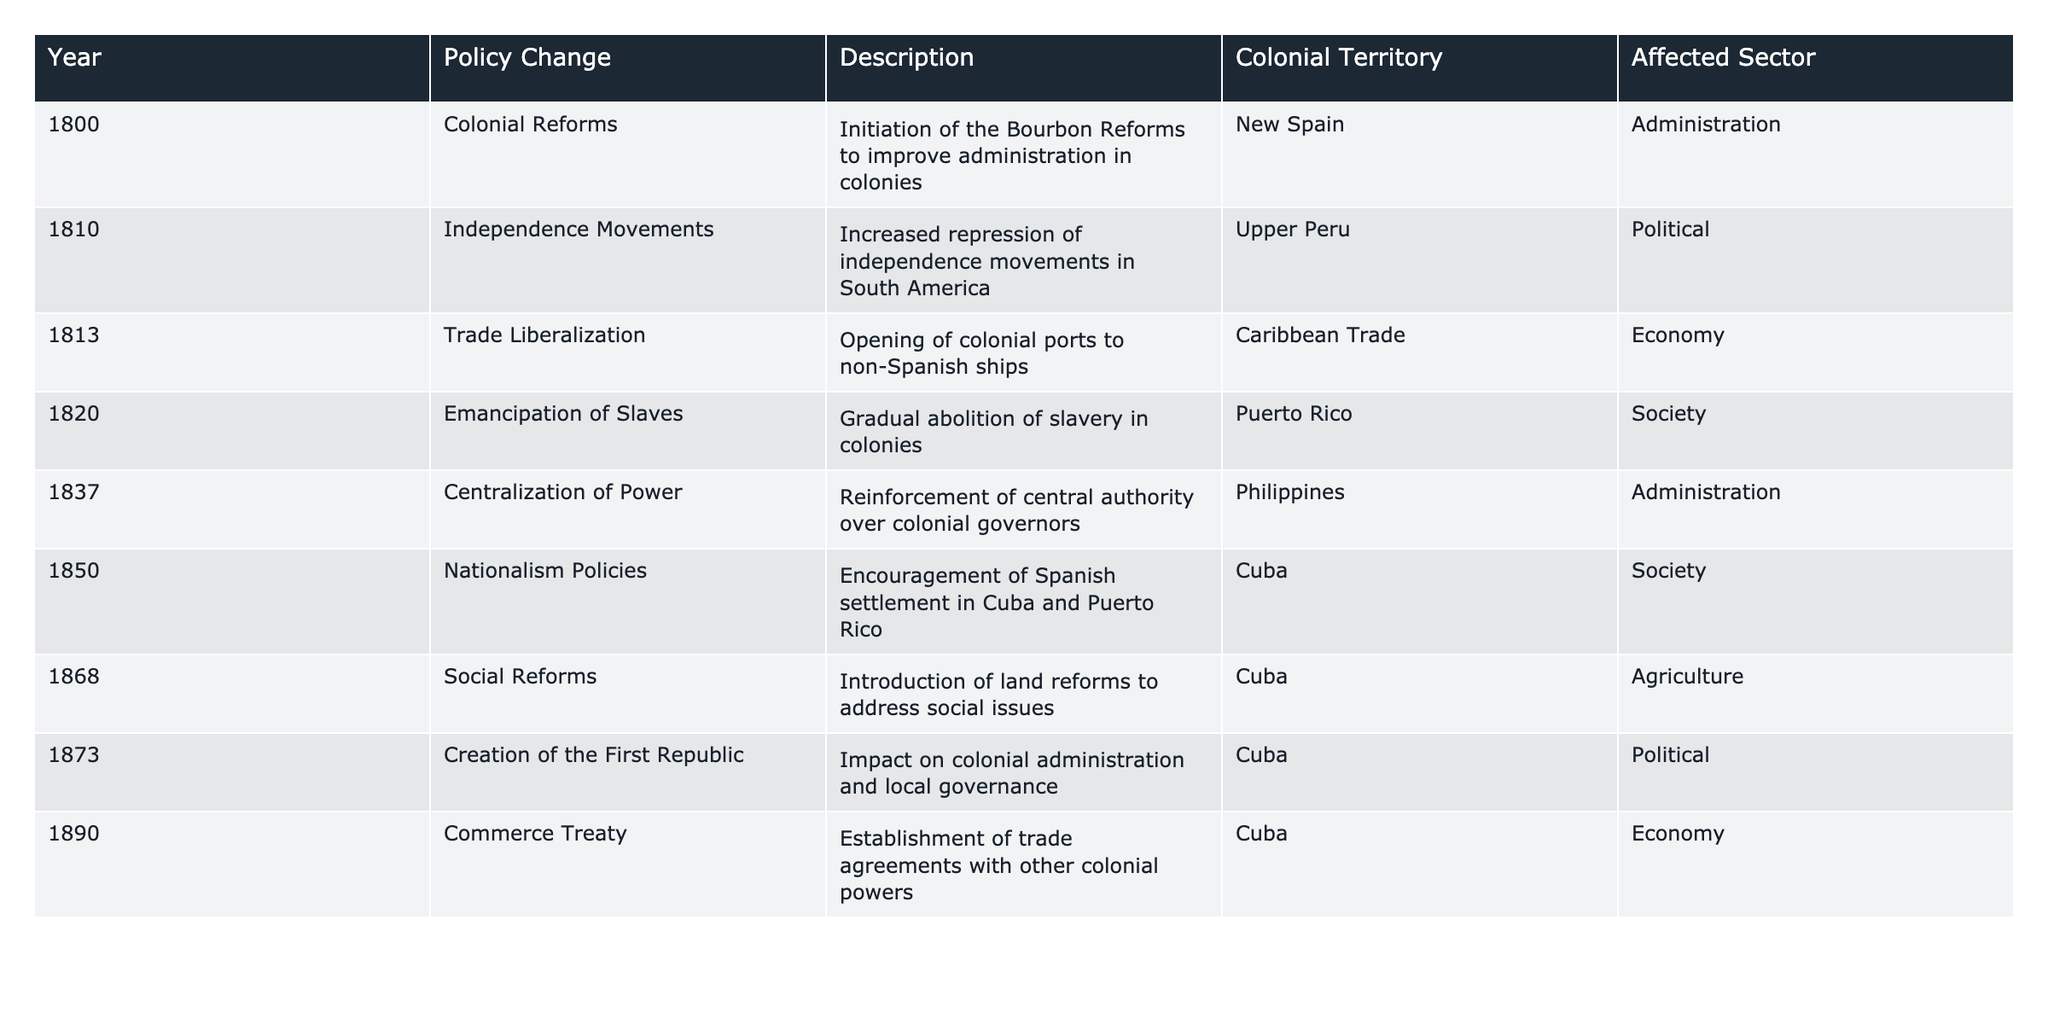What year did the colonial reforms begin? The table presents a specific entry for the year 1800, which states that colonial reforms were initiated.
Answer: 1800 What colonial territory experienced increased repression of independence movements in 1810? The table indicates that the policy change related to independence movements occurred specifically in Upper Peru during the year 1810.
Answer: Upper Peru How many different sectors are affected by the policies listed in the table? Reviewing the affected sector column, the sectors are Administration, Political, Economy, Society, and Agriculture. Counting them gives a total of five distinct sectors.
Answer: 5 Was there a policy change related to the emancipation of slaves? The table explicitly states that in 1820, there was a policy change regarding the gradual abolition of slavery in Puerto Rico, confirming a change related to emancipation.
Answer: Yes Which policy change affected the economy in 1813? According to the table, the trade liberalization policy that opened colonial ports to non-Spanish ships in the Caribbean Trade was the one affecting the economy in 1813.
Answer: Trade Liberalization What was the last policy change mentioned in the table? By looking at the year column in the table, the last entry is for the year 1890, which relates to the commerce treaty established with other colonial powers.
Answer: 1890 How many policy changes were related to societal impacts? From the table, there are two entries that mention the affected sector as Society: the emancipation of slaves in 1820 and nationalism policies in 1850. Adding these gives a total of two societal-focused policy changes.
Answer: 2 Which colonial territory underwent land reforms in 1868? The table specifies that social reforms, including land reforms, took place in Cuba during the year 1868.
Answer: Cuba What is the difference in years between the initiation of colonial reforms and the social reforms introduced in 1868? The table lists 1800 as the year when colonial reforms began and 1868 for the social reforms. The difference, calculated as 1868 - 1800, equals 68 years.
Answer: 68 Which policy aimed at centralizing power in 1837? Referring to the table, the centralization of power policy change is noted for the year 1837, specifically reinforcing central authority over colonial governors in the Philippines.
Answer: Centralization of Power 